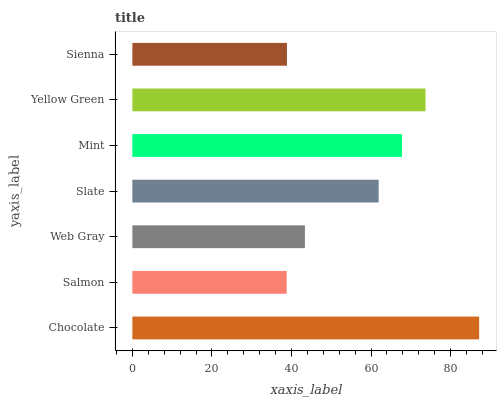Is Salmon the minimum?
Answer yes or no. Yes. Is Chocolate the maximum?
Answer yes or no. Yes. Is Web Gray the minimum?
Answer yes or no. No. Is Web Gray the maximum?
Answer yes or no. No. Is Web Gray greater than Salmon?
Answer yes or no. Yes. Is Salmon less than Web Gray?
Answer yes or no. Yes. Is Salmon greater than Web Gray?
Answer yes or no. No. Is Web Gray less than Salmon?
Answer yes or no. No. Is Slate the high median?
Answer yes or no. Yes. Is Slate the low median?
Answer yes or no. Yes. Is Web Gray the high median?
Answer yes or no. No. Is Sienna the low median?
Answer yes or no. No. 